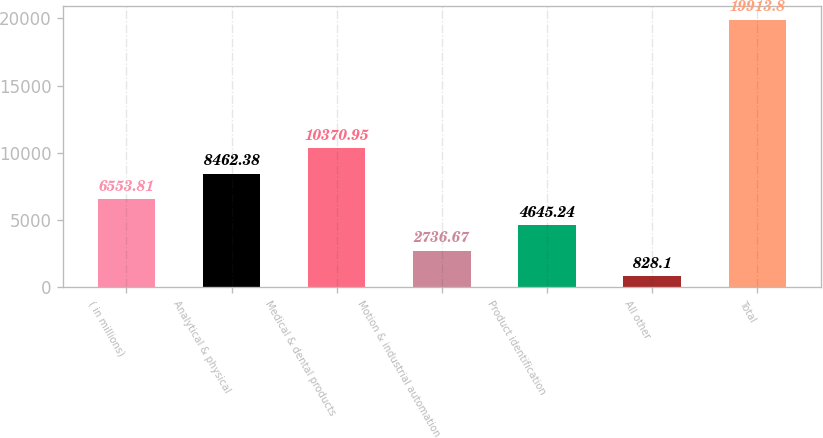Convert chart. <chart><loc_0><loc_0><loc_500><loc_500><bar_chart><fcel>( in millions)<fcel>Analytical & physical<fcel>Medical & dental products<fcel>Motion & industrial automation<fcel>Product identification<fcel>All other<fcel>Total<nl><fcel>6553.81<fcel>8462.38<fcel>10371<fcel>2736.67<fcel>4645.24<fcel>828.1<fcel>19913.8<nl></chart> 